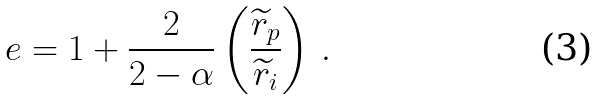Convert formula to latex. <formula><loc_0><loc_0><loc_500><loc_500>e = 1 + \frac { 2 } { 2 - \alpha } \left ( \frac { \widetilde { r } _ { p } } { \widetilde { r } _ { i } } \right ) \, .</formula> 